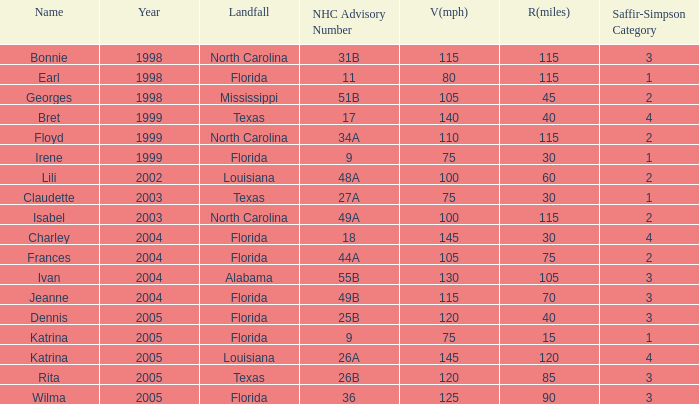What was the highest SaffirSimpson with an NHC advisory of 18? 4.0. 